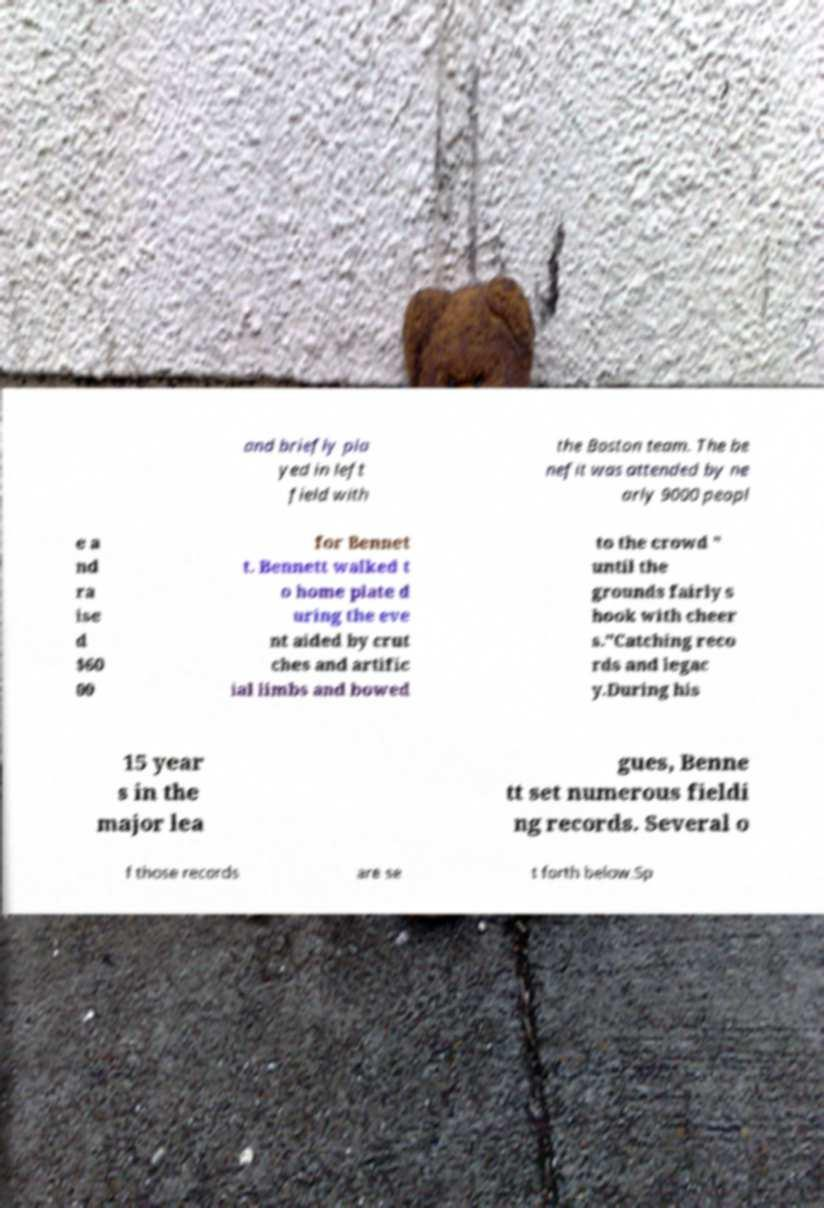Could you assist in decoding the text presented in this image and type it out clearly? and briefly pla yed in left field with the Boston team. The be nefit was attended by ne arly 9000 peopl e a nd ra ise d $60 00 for Bennet t. Bennett walked t o home plate d uring the eve nt aided by crut ches and artific ial limbs and bowed to the crowd " until the grounds fairly s hook with cheer s."Catching reco rds and legac y.During his 15 year s in the major lea gues, Benne tt set numerous fieldi ng records. Several o f those records are se t forth below.Sp 